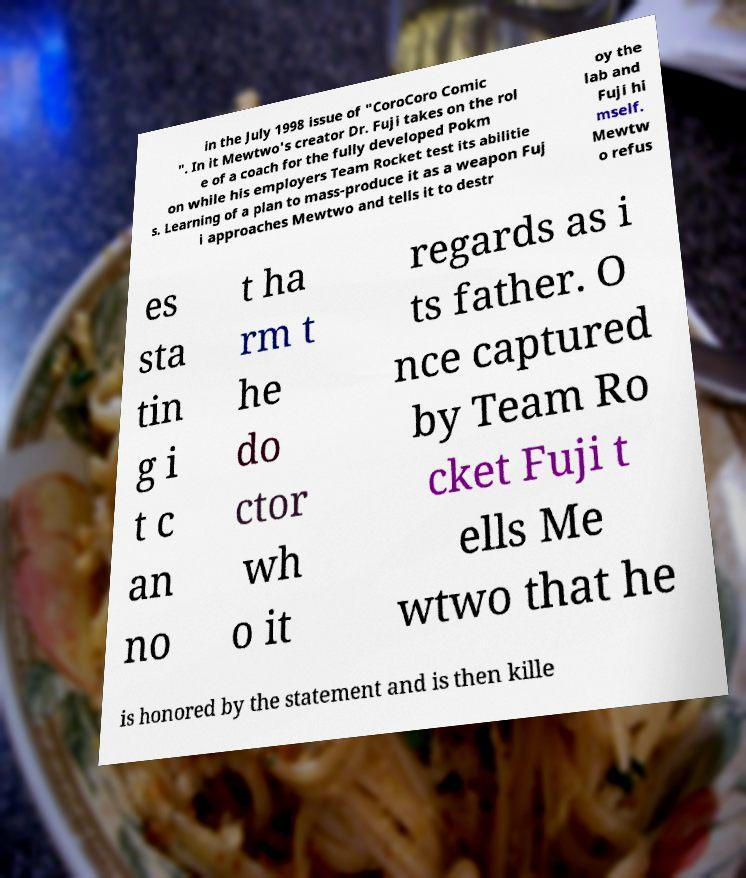I need the written content from this picture converted into text. Can you do that? in the July 1998 issue of "CoroCoro Comic ". In it Mewtwo's creator Dr. Fuji takes on the rol e of a coach for the fully developed Pokm on while his employers Team Rocket test its abilitie s. Learning of a plan to mass-produce it as a weapon Fuj i approaches Mewtwo and tells it to destr oy the lab and Fuji hi mself. Mewtw o refus es sta tin g i t c an no t ha rm t he do ctor wh o it regards as i ts father. O nce captured by Team Ro cket Fuji t ells Me wtwo that he is honored by the statement and is then kille 